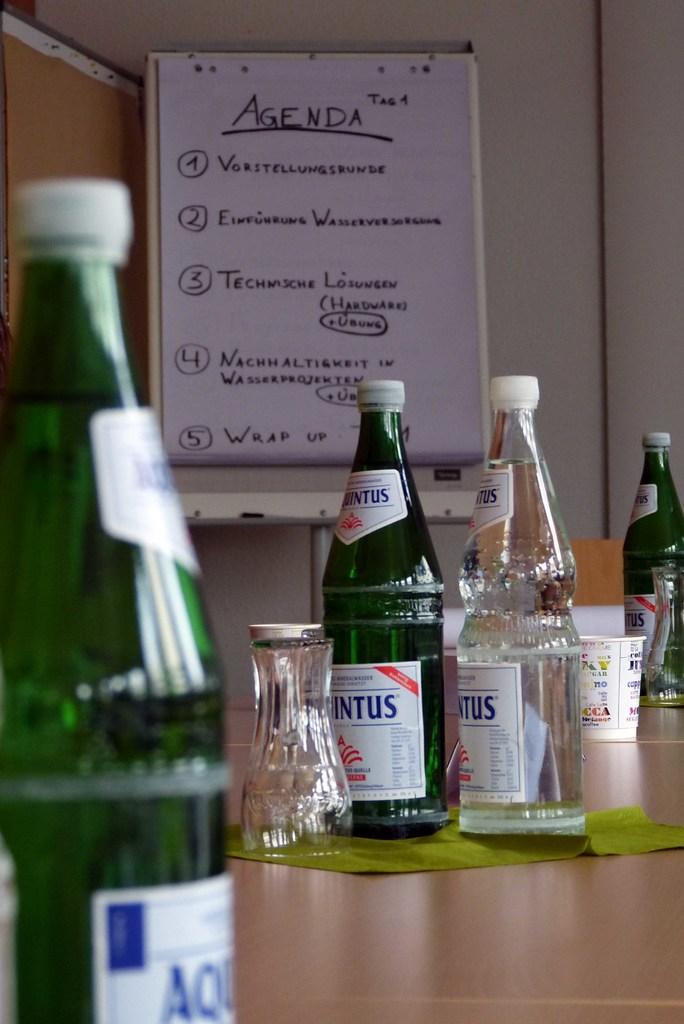What brand is shown?
Ensure brevity in your answer.  Aquintus. 